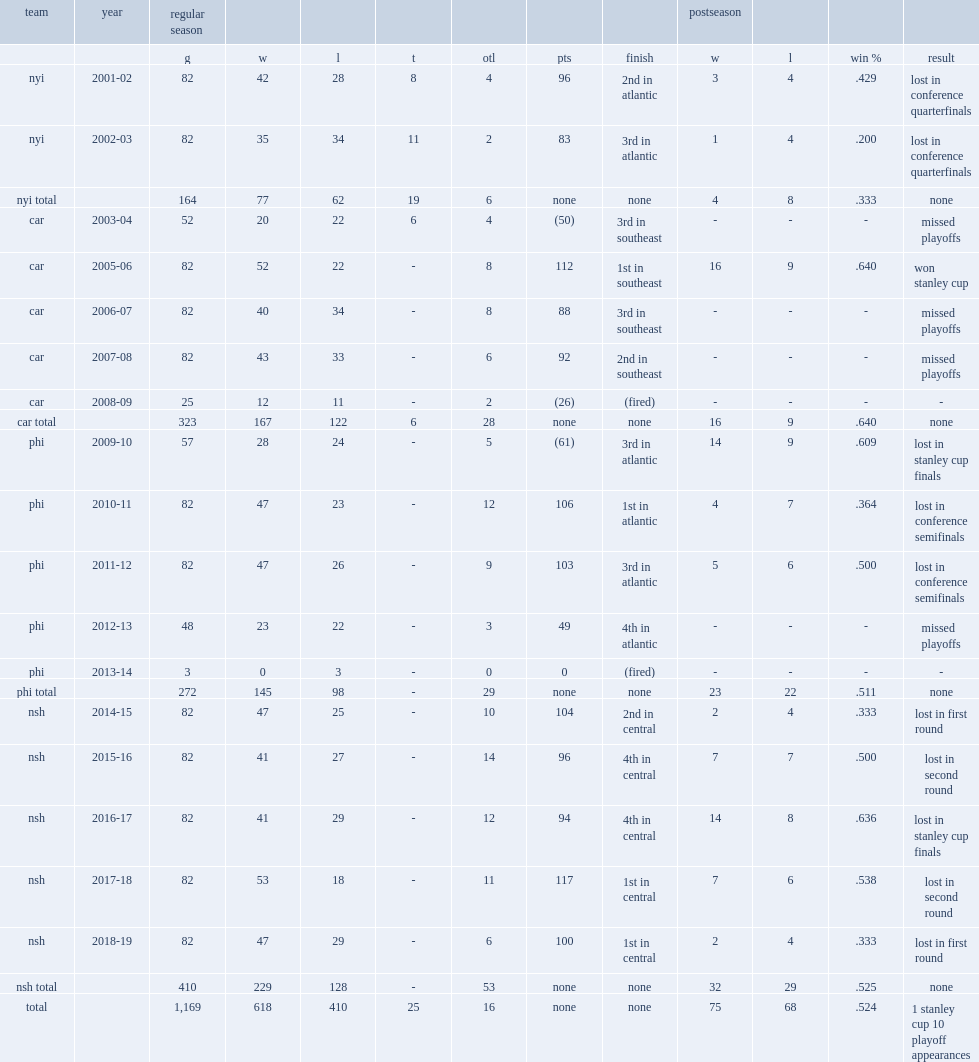How many points did laviolette get in the southeast division ? 112.0. 